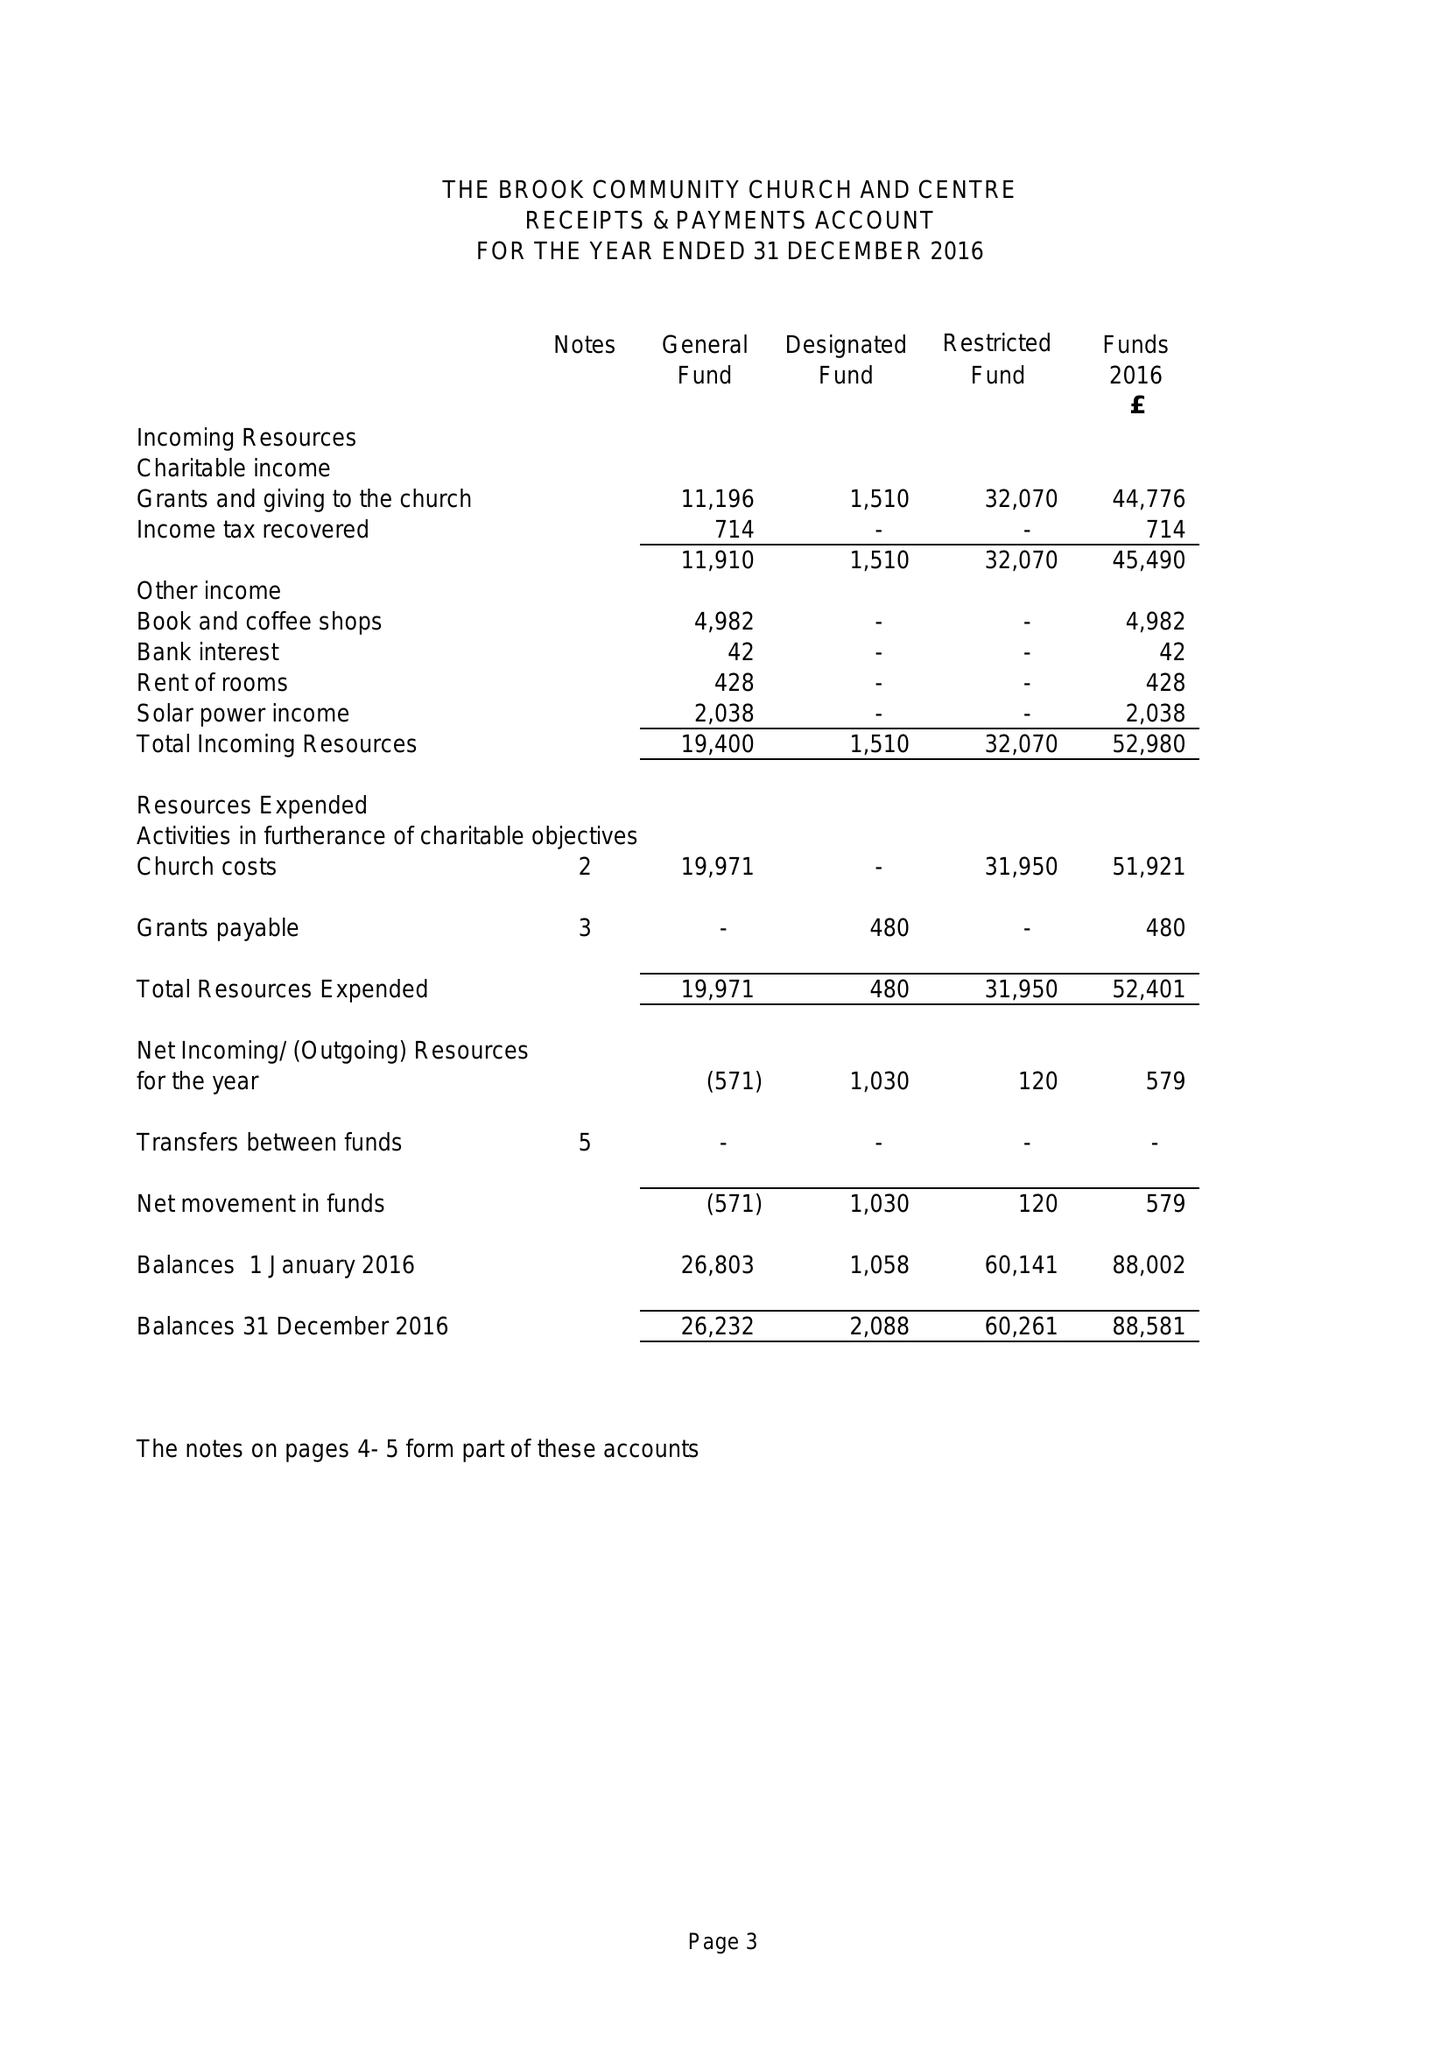What is the value for the income_annually_in_british_pounds?
Answer the question using a single word or phrase. 52980.00 